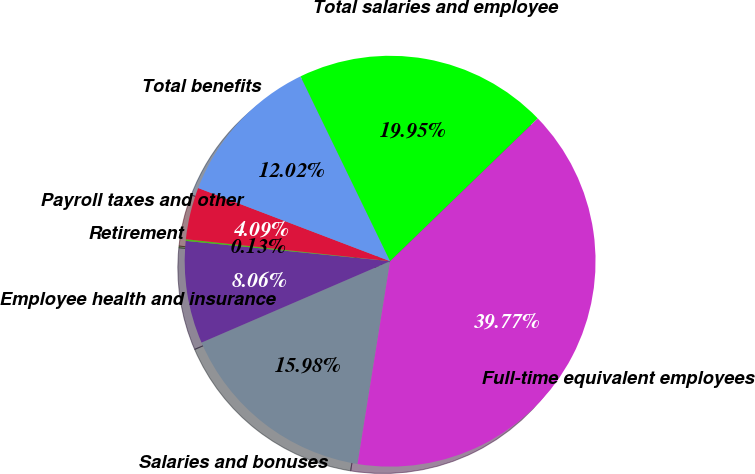Convert chart to OTSL. <chart><loc_0><loc_0><loc_500><loc_500><pie_chart><fcel>Salaries and bonuses<fcel>Employee health and insurance<fcel>Retirement<fcel>Payroll taxes and other<fcel>Total benefits<fcel>Total salaries and employee<fcel>Full-time equivalent employees<nl><fcel>15.98%<fcel>8.06%<fcel>0.13%<fcel>4.09%<fcel>12.02%<fcel>19.95%<fcel>39.77%<nl></chart> 